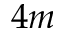Convert formula to latex. <formula><loc_0><loc_0><loc_500><loc_500>4 m</formula> 